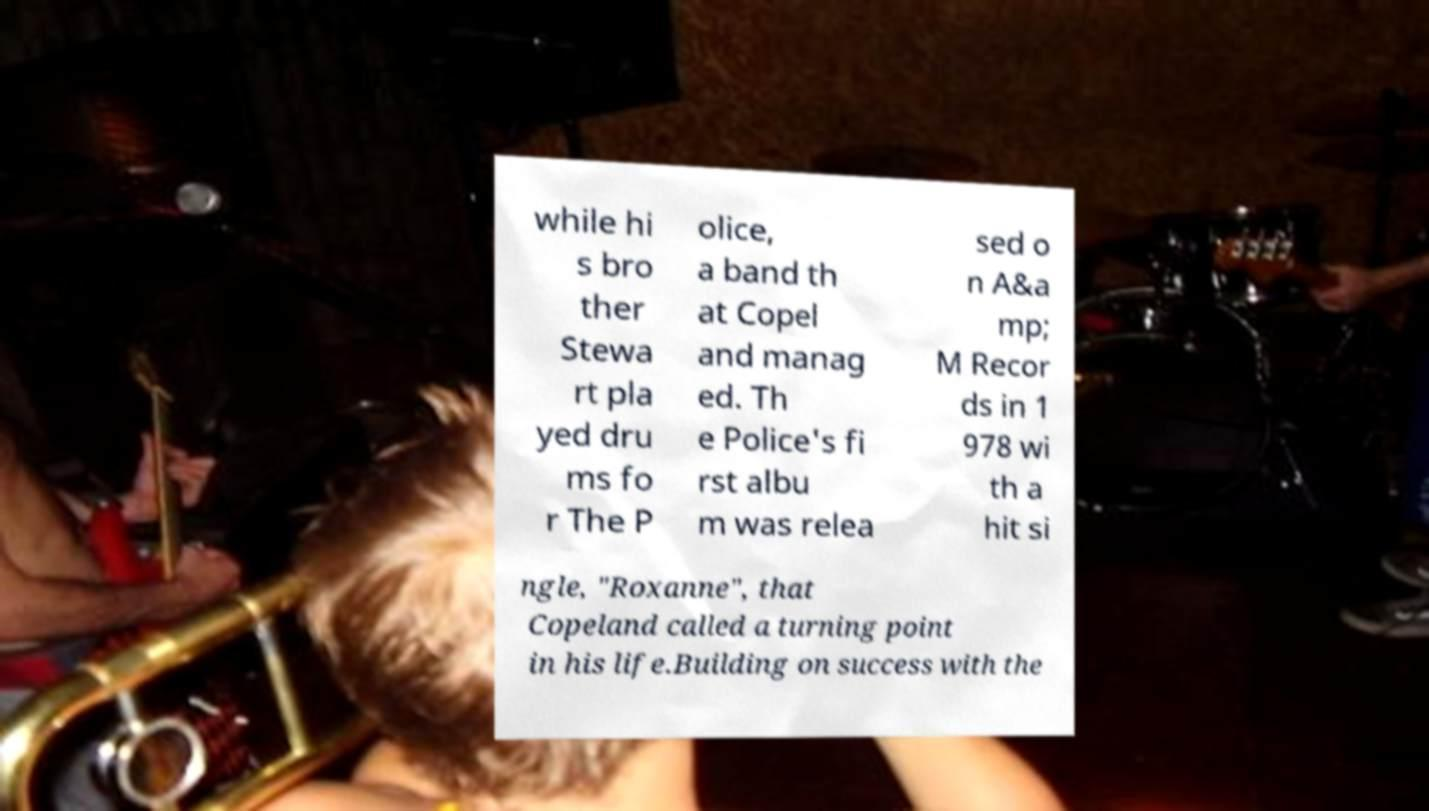There's text embedded in this image that I need extracted. Can you transcribe it verbatim? while hi s bro ther Stewa rt pla yed dru ms fo r The P olice, a band th at Copel and manag ed. Th e Police's fi rst albu m was relea sed o n A&a mp; M Recor ds in 1 978 wi th a hit si ngle, "Roxanne", that Copeland called a turning point in his life.Building on success with the 